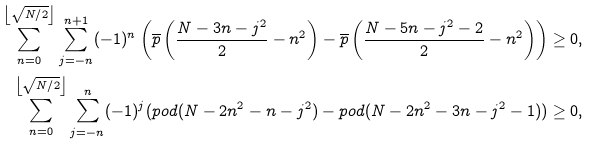Convert formula to latex. <formula><loc_0><loc_0><loc_500><loc_500>\sum _ { n = 0 } ^ { \left \lfloor \sqrt { N / 2 } \right \rfloor } \sum _ { j = - n } ^ { n + 1 } ( - 1 ) ^ { n } \left ( \overline { p } \left ( \frac { N - 3 n - j ^ { 2 } } { 2 } - n ^ { 2 } \right ) - \overline { p } \left ( \frac { N - 5 n - j ^ { 2 } - 2 } { 2 } - n ^ { 2 } \right ) \right ) & \geq 0 , \\ \sum _ { n = 0 } ^ { \left \lfloor \sqrt { N / 2 } \right \rfloor } \sum _ { j = - n } ^ { n } ( - 1 ) ^ { j } ( p o d ( N - 2 n ^ { 2 } - n - j ^ { 2 } ) - p o d ( N - 2 n ^ { 2 } - 3 n - j ^ { 2 } - 1 ) ) & \geq 0 ,</formula> 